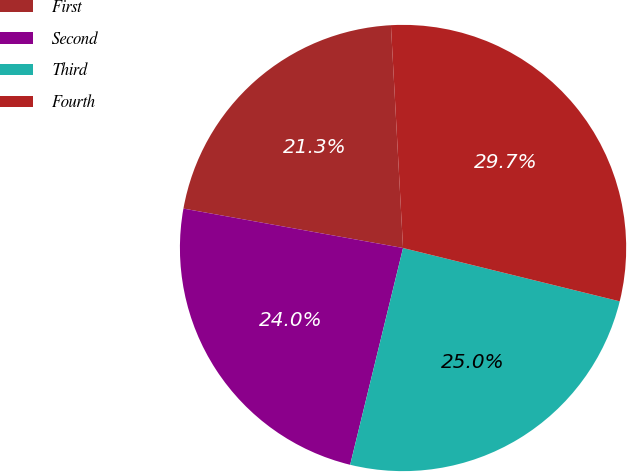Convert chart. <chart><loc_0><loc_0><loc_500><loc_500><pie_chart><fcel>First<fcel>Second<fcel>Third<fcel>Fourth<nl><fcel>21.31%<fcel>24.02%<fcel>24.97%<fcel>29.71%<nl></chart> 